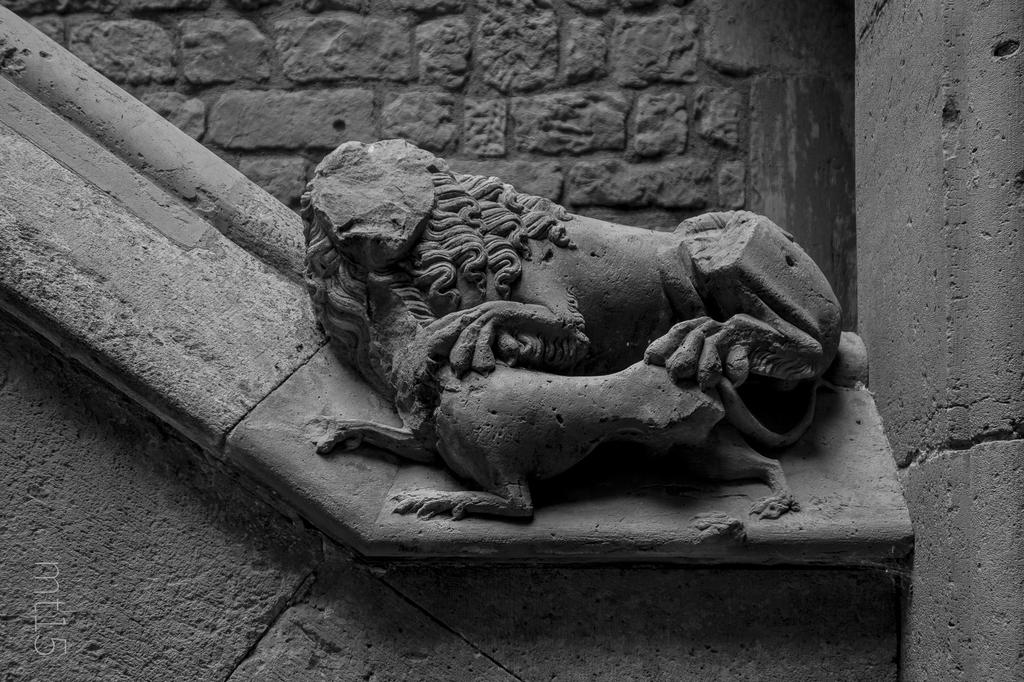What is the main subject of the image? The main subject of the image is a sculpture. How is the sculpture positioned in the image? The sculpture is attached to the wall. What type of slope can be seen in the image? There is no slope present in the image; it features a sculpture attached to the wall. How many goldfish are swimming in the image? There are no goldfish present in the image; it features a sculpture attached to the wall. 